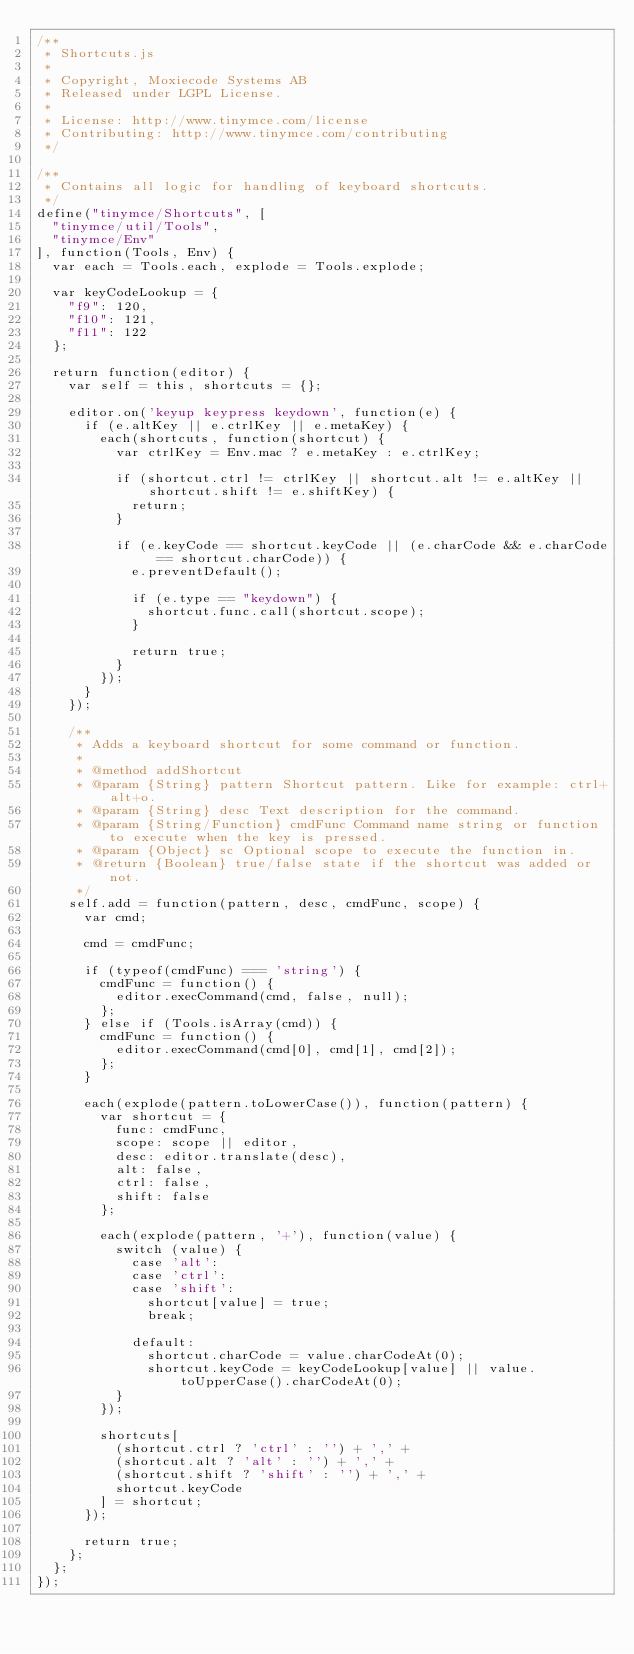<code> <loc_0><loc_0><loc_500><loc_500><_JavaScript_>/**
 * Shortcuts.js
 *
 * Copyright, Moxiecode Systems AB
 * Released under LGPL License.
 *
 * License: http://www.tinymce.com/license
 * Contributing: http://www.tinymce.com/contributing
 */

/**
 * Contains all logic for handling of keyboard shortcuts.
 */
define("tinymce/Shortcuts", [
	"tinymce/util/Tools",
	"tinymce/Env"
], function(Tools, Env) {
	var each = Tools.each, explode = Tools.explode;

	var keyCodeLookup = {
		"f9": 120,
		"f10": 121,
		"f11": 122
	};

	return function(editor) {
		var self = this, shortcuts = {};

		editor.on('keyup keypress keydown', function(e) {
			if (e.altKey || e.ctrlKey || e.metaKey) {
				each(shortcuts, function(shortcut) {
					var ctrlKey = Env.mac ? e.metaKey : e.ctrlKey;

					if (shortcut.ctrl != ctrlKey || shortcut.alt != e.altKey || shortcut.shift != e.shiftKey) {
						return;
					}

					if (e.keyCode == shortcut.keyCode || (e.charCode && e.charCode == shortcut.charCode)) {
						e.preventDefault();

						if (e.type == "keydown") {
							shortcut.func.call(shortcut.scope);
						}

						return true;
					}
				});
			}
		});

		/**
		 * Adds a keyboard shortcut for some command or function.
		 *
		 * @method addShortcut
		 * @param {String} pattern Shortcut pattern. Like for example: ctrl+alt+o.
		 * @param {String} desc Text description for the command.
		 * @param {String/Function} cmdFunc Command name string or function to execute when the key is pressed.
		 * @param {Object} sc Optional scope to execute the function in.
		 * @return {Boolean} true/false state if the shortcut was added or not.
		 */
		self.add = function(pattern, desc, cmdFunc, scope) {
			var cmd;

			cmd = cmdFunc;

			if (typeof(cmdFunc) === 'string') {
				cmdFunc = function() {
					editor.execCommand(cmd, false, null);
				};
			} else if (Tools.isArray(cmd)) {
				cmdFunc = function() {
					editor.execCommand(cmd[0], cmd[1], cmd[2]);
				};
			}

			each(explode(pattern.toLowerCase()), function(pattern) {
				var shortcut = {
					func: cmdFunc,
					scope: scope || editor,
					desc: editor.translate(desc),
					alt: false,
					ctrl: false,
					shift: false
				};

				each(explode(pattern, '+'), function(value) {
					switch (value) {
						case 'alt':
						case 'ctrl':
						case 'shift':
							shortcut[value] = true;
							break;

						default:
							shortcut.charCode = value.charCodeAt(0);
							shortcut.keyCode = keyCodeLookup[value] || value.toUpperCase().charCodeAt(0);
					}
				});

				shortcuts[
					(shortcut.ctrl ? 'ctrl' : '') + ',' +
					(shortcut.alt ? 'alt' : '') + ',' +
					(shortcut.shift ? 'shift' : '') + ',' +
					shortcut.keyCode
				] = shortcut;
			});

			return true;
		};
	};
});</code> 